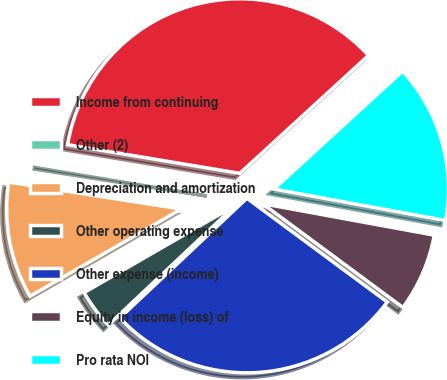<chart> <loc_0><loc_0><loc_500><loc_500><pie_chart><fcel>Income from continuing<fcel>Other (2)<fcel>Depreciation and amortization<fcel>Other operating expense<fcel>Other expense (income)<fcel>Equity in income (loss) of<fcel>Pro rata NOI<nl><fcel>35.57%<fcel>0.16%<fcel>10.79%<fcel>3.7%<fcel>27.84%<fcel>7.25%<fcel>14.69%<nl></chart> 